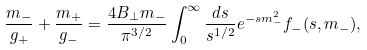Convert formula to latex. <formula><loc_0><loc_0><loc_500><loc_500>\frac { m _ { - } } { g _ { + } } + \frac { m _ { + } } { g _ { - } } = \frac { 4 B _ { \bot } m _ { - } } { \pi ^ { 3 / 2 } } \int _ { 0 } ^ { \infty } \frac { d s } { s ^ { 1 / 2 } } e ^ { - s m _ { - } ^ { 2 } } f _ { - } ( s , m _ { - } ) ,</formula> 